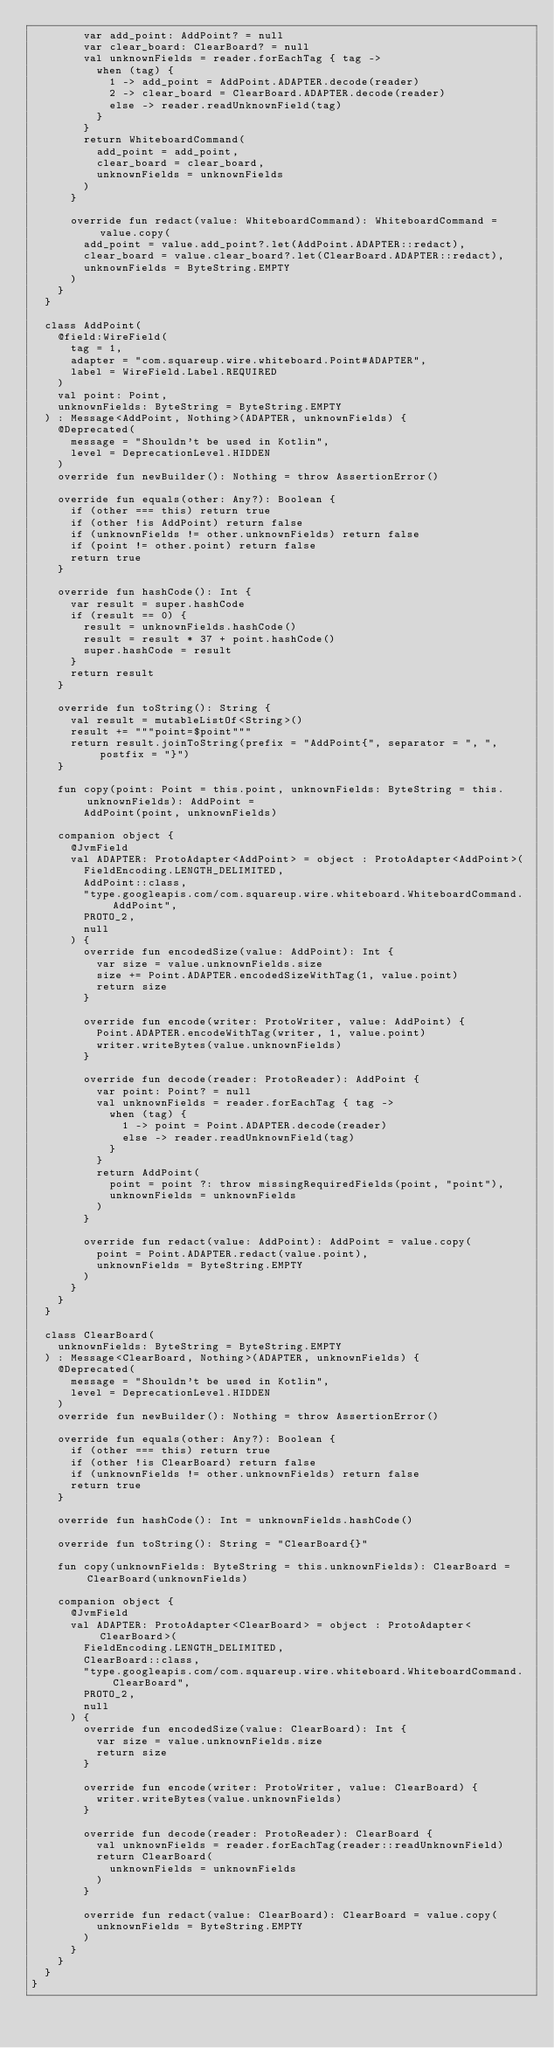Convert code to text. <code><loc_0><loc_0><loc_500><loc_500><_Kotlin_>        var add_point: AddPoint? = null
        var clear_board: ClearBoard? = null
        val unknownFields = reader.forEachTag { tag ->
          when (tag) {
            1 -> add_point = AddPoint.ADAPTER.decode(reader)
            2 -> clear_board = ClearBoard.ADAPTER.decode(reader)
            else -> reader.readUnknownField(tag)
          }
        }
        return WhiteboardCommand(
          add_point = add_point,
          clear_board = clear_board,
          unknownFields = unknownFields
        )
      }

      override fun redact(value: WhiteboardCommand): WhiteboardCommand = value.copy(
        add_point = value.add_point?.let(AddPoint.ADAPTER::redact),
        clear_board = value.clear_board?.let(ClearBoard.ADAPTER::redact),
        unknownFields = ByteString.EMPTY
      )
    }
  }

  class AddPoint(
    @field:WireField(
      tag = 1,
      adapter = "com.squareup.wire.whiteboard.Point#ADAPTER",
      label = WireField.Label.REQUIRED
    )
    val point: Point,
    unknownFields: ByteString = ByteString.EMPTY
  ) : Message<AddPoint, Nothing>(ADAPTER, unknownFields) {
    @Deprecated(
      message = "Shouldn't be used in Kotlin",
      level = DeprecationLevel.HIDDEN
    )
    override fun newBuilder(): Nothing = throw AssertionError()

    override fun equals(other: Any?): Boolean {
      if (other === this) return true
      if (other !is AddPoint) return false
      if (unknownFields != other.unknownFields) return false
      if (point != other.point) return false
      return true
    }

    override fun hashCode(): Int {
      var result = super.hashCode
      if (result == 0) {
        result = unknownFields.hashCode()
        result = result * 37 + point.hashCode()
        super.hashCode = result
      }
      return result
    }

    override fun toString(): String {
      val result = mutableListOf<String>()
      result += """point=$point"""
      return result.joinToString(prefix = "AddPoint{", separator = ", ", postfix = "}")
    }

    fun copy(point: Point = this.point, unknownFields: ByteString = this.unknownFields): AddPoint =
        AddPoint(point, unknownFields)

    companion object {
      @JvmField
      val ADAPTER: ProtoAdapter<AddPoint> = object : ProtoAdapter<AddPoint>(
        FieldEncoding.LENGTH_DELIMITED, 
        AddPoint::class, 
        "type.googleapis.com/com.squareup.wire.whiteboard.WhiteboardCommand.AddPoint", 
        PROTO_2, 
        null
      ) {
        override fun encodedSize(value: AddPoint): Int {
          var size = value.unknownFields.size
          size += Point.ADAPTER.encodedSizeWithTag(1, value.point)
          return size
        }

        override fun encode(writer: ProtoWriter, value: AddPoint) {
          Point.ADAPTER.encodeWithTag(writer, 1, value.point)
          writer.writeBytes(value.unknownFields)
        }

        override fun decode(reader: ProtoReader): AddPoint {
          var point: Point? = null
          val unknownFields = reader.forEachTag { tag ->
            when (tag) {
              1 -> point = Point.ADAPTER.decode(reader)
              else -> reader.readUnknownField(tag)
            }
          }
          return AddPoint(
            point = point ?: throw missingRequiredFields(point, "point"),
            unknownFields = unknownFields
          )
        }

        override fun redact(value: AddPoint): AddPoint = value.copy(
          point = Point.ADAPTER.redact(value.point),
          unknownFields = ByteString.EMPTY
        )
      }
    }
  }

  class ClearBoard(
    unknownFields: ByteString = ByteString.EMPTY
  ) : Message<ClearBoard, Nothing>(ADAPTER, unknownFields) {
    @Deprecated(
      message = "Shouldn't be used in Kotlin",
      level = DeprecationLevel.HIDDEN
    )
    override fun newBuilder(): Nothing = throw AssertionError()

    override fun equals(other: Any?): Boolean {
      if (other === this) return true
      if (other !is ClearBoard) return false
      if (unknownFields != other.unknownFields) return false
      return true
    }

    override fun hashCode(): Int = unknownFields.hashCode()

    override fun toString(): String = "ClearBoard{}"

    fun copy(unknownFields: ByteString = this.unknownFields): ClearBoard = ClearBoard(unknownFields)

    companion object {
      @JvmField
      val ADAPTER: ProtoAdapter<ClearBoard> = object : ProtoAdapter<ClearBoard>(
        FieldEncoding.LENGTH_DELIMITED, 
        ClearBoard::class, 
        "type.googleapis.com/com.squareup.wire.whiteboard.WhiteboardCommand.ClearBoard", 
        PROTO_2, 
        null
      ) {
        override fun encodedSize(value: ClearBoard): Int {
          var size = value.unknownFields.size
          return size
        }

        override fun encode(writer: ProtoWriter, value: ClearBoard) {
          writer.writeBytes(value.unknownFields)
        }

        override fun decode(reader: ProtoReader): ClearBoard {
          val unknownFields = reader.forEachTag(reader::readUnknownField)
          return ClearBoard(
            unknownFields = unknownFields
          )
        }

        override fun redact(value: ClearBoard): ClearBoard = value.copy(
          unknownFields = ByteString.EMPTY
        )
      }
    }
  }
}
</code> 